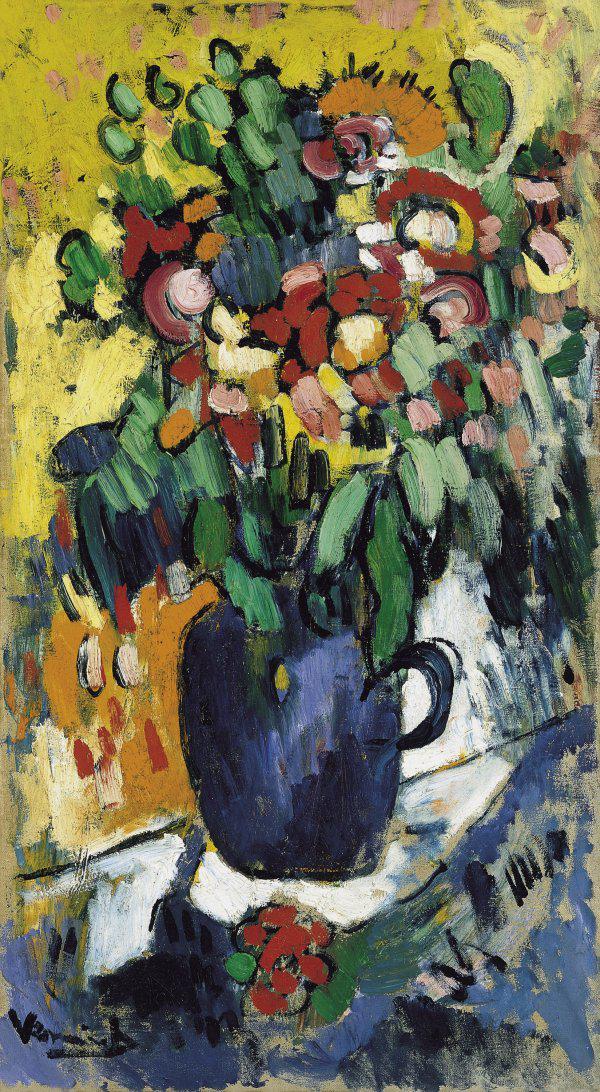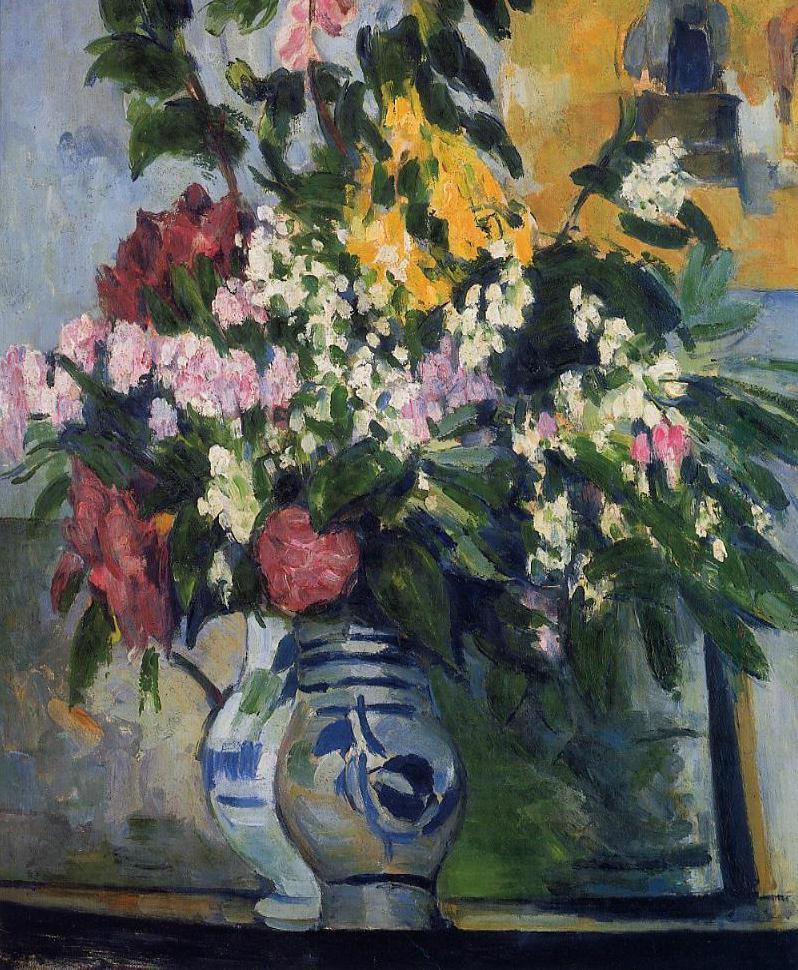The first image is the image on the left, the second image is the image on the right. Analyze the images presented: Is the assertion "One of the pictures shows a vase on a table with at least three round fruit also displayed on the table." valid? Answer yes or no. No. The first image is the image on the left, the second image is the image on the right. Examine the images to the left and right. Is the description "In one image there is a vase of flowers next to several pieces of fruit on a tabletop." accurate? Answer yes or no. No. 